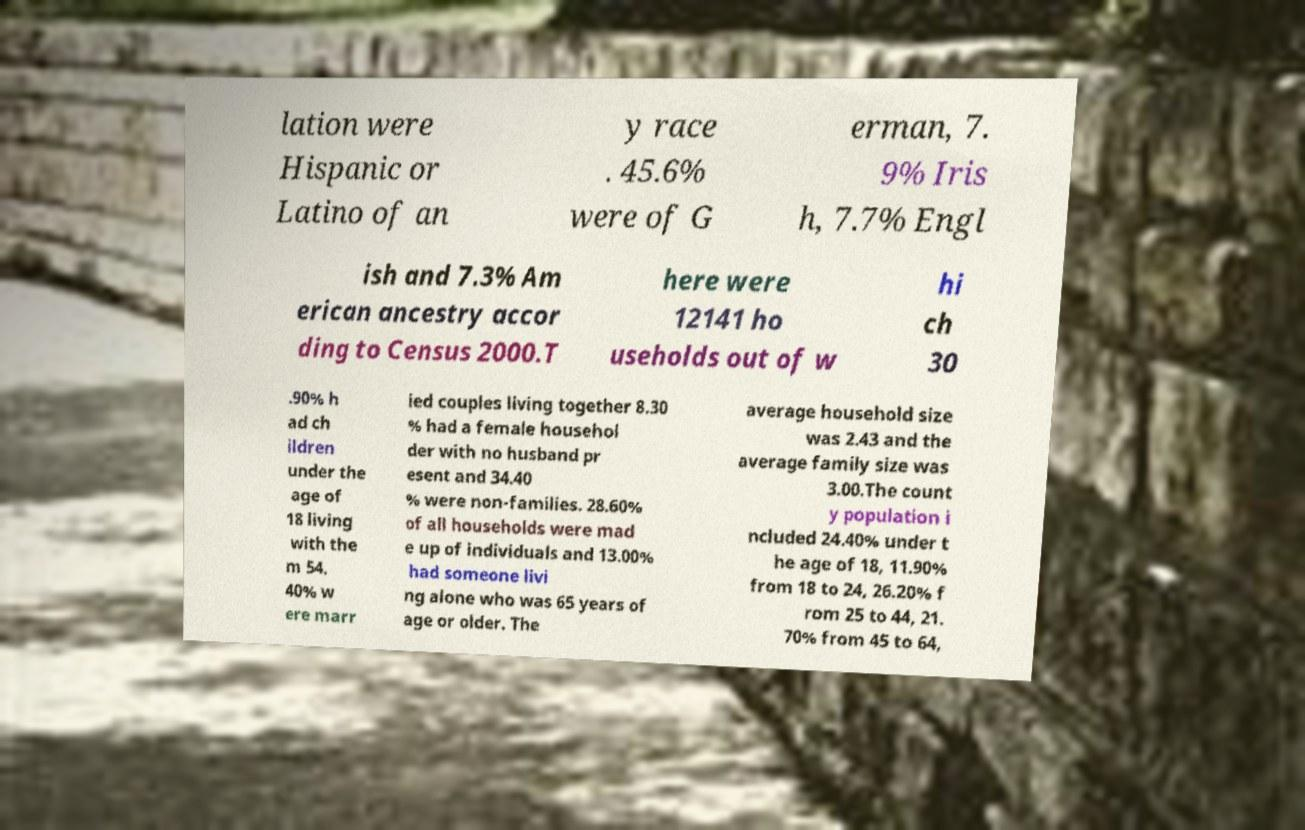For documentation purposes, I need the text within this image transcribed. Could you provide that? lation were Hispanic or Latino of an y race . 45.6% were of G erman, 7. 9% Iris h, 7.7% Engl ish and 7.3% Am erican ancestry accor ding to Census 2000.T here were 12141 ho useholds out of w hi ch 30 .90% h ad ch ildren under the age of 18 living with the m 54. 40% w ere marr ied couples living together 8.30 % had a female househol der with no husband pr esent and 34.40 % were non-families. 28.60% of all households were mad e up of individuals and 13.00% had someone livi ng alone who was 65 years of age or older. The average household size was 2.43 and the average family size was 3.00.The count y population i ncluded 24.40% under t he age of 18, 11.90% from 18 to 24, 26.20% f rom 25 to 44, 21. 70% from 45 to 64, 